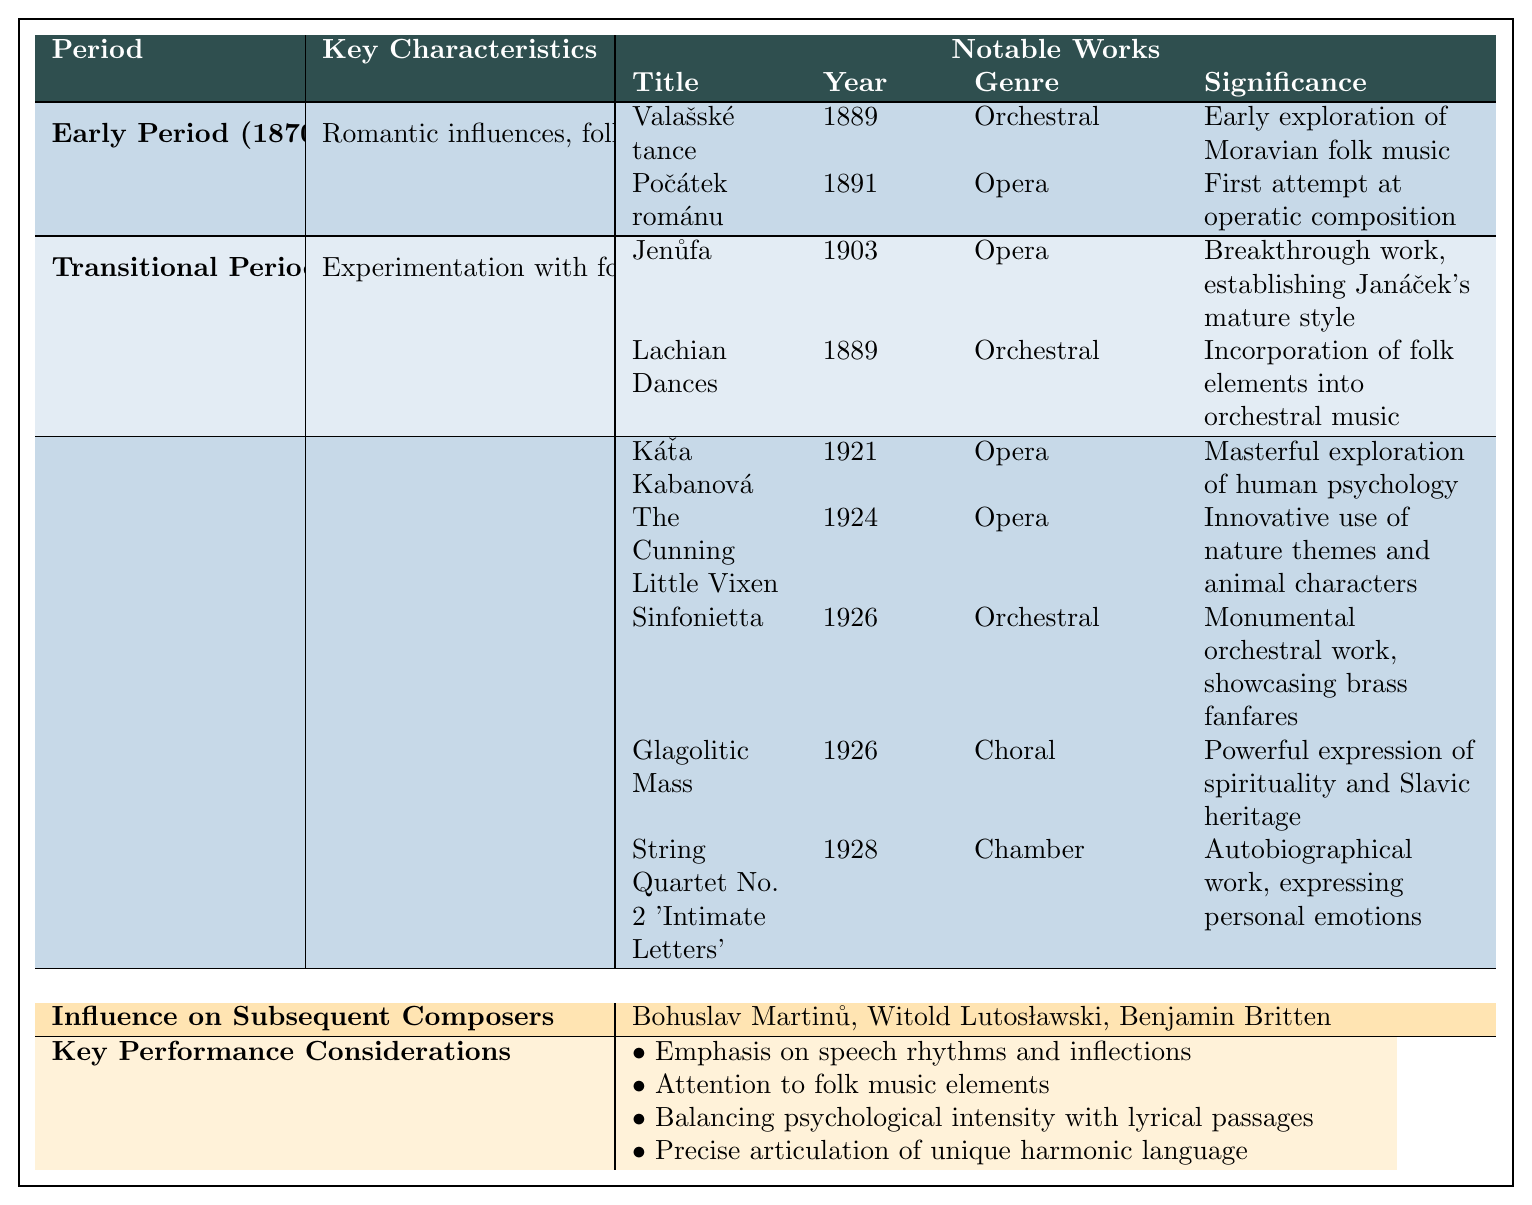What is the primary characteristic of Janáček's Mature Period? The primary characteristic includes unique speech-melody technique and psychological depth, as noted in the table.
Answer: Unique speech-melody technique and psychological depth Which work was composed in the year 1926? Referring to the table, both "Sinfonietta" and "Glagolitic Mass" were composed in 1926.
Answer: Sinfonietta and Glagolitic Mass True or False: "Jenůfa" was composed in Janáček's Early Period. The table shows that "Jenůfa" was composed in 1903, which falls under the Transitional Period, not the Early Period.
Answer: False How many notable works are listed for the Early Period? The table indicates that there are two notable works listed for the Early Period: "Valašské tance" and "Počátek románu."
Answer: 2 What significant change in focus occurred from the Early Period to the Transitional Period? The Early Period focused on Romantic influences and folk music inspiration, while the Transitional Period emphasized experimentation with form and a growing interest in speech melodies, as indicated in the respective sections.
Answer: Experimentation with form and interest in speech melodies Identify one composer influenced by Janáček's work. According to the table, "Bohuslav Martinů" is mentioned as one of the composers influenced by Janáček.
Answer: Bohuslav Martinů What percentage of Janáček's notable works in the Mature Period are operas? There are 5 notable works listed for the Mature Period, with 3 of those being operas ("Káťa Kabanová," "The Cunning Little Vixen," and "String Quartet No. 2"), so (3/5) * 100 = 60%.
Answer: 60% Which work signifies Janáček's first attempt at operatic composition? The table clearly indicates that "Počátek románu" represents Janáček's first attempt at operatic composition, as listed under the Early Period.
Answer: Počátek románu What common theme is present in both "Sinfonietta" and "Glagolitic Mass"? Both works express significant cultural and psychological themes, with "Sinfonietta" showcasing brass fanfares and "Glagolitic Mass" presenting a powerful expression of spirituality and Slavic heritage, thus exhibiting a connection to Janáček's exploration of human and cultural spirit.
Answer: Cultural and psychological themes How many periods are mentioned in Janáček's compositional overview? The table outlines three distinct periods of Janáček's compositional timeline: Early Period, Transitional Period, and Mature Period.
Answer: 3 What is a key aspect that performers should consider when interpreting Janáček's music? The table lists several key performance considerations, including the emphasis on speech rhythms and inflections, which underscores the importance of how the music relates to natural speech.
Answer: Emphasis on speech rhythms and inflections 